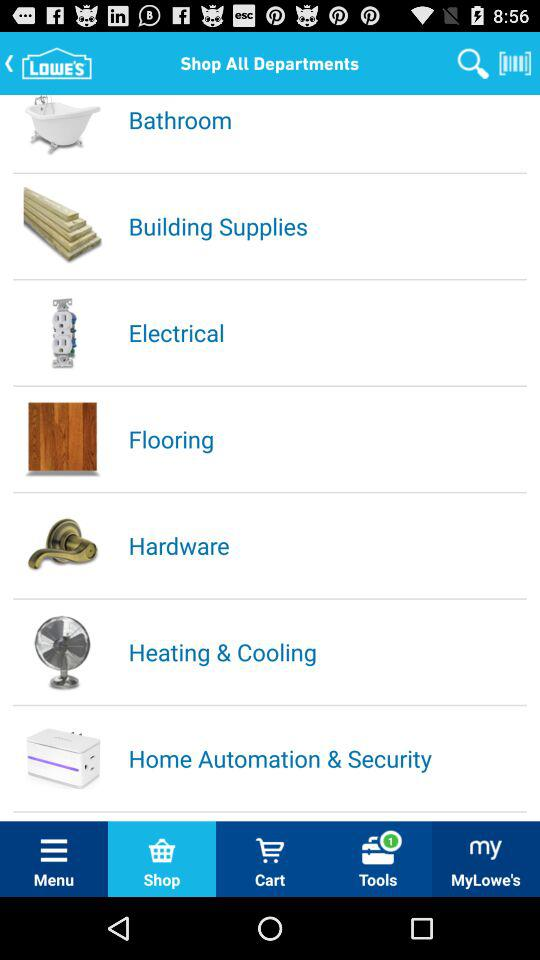What is the number of new notifications in "Tools"? The number of new notifications in "Tools" is 1. 